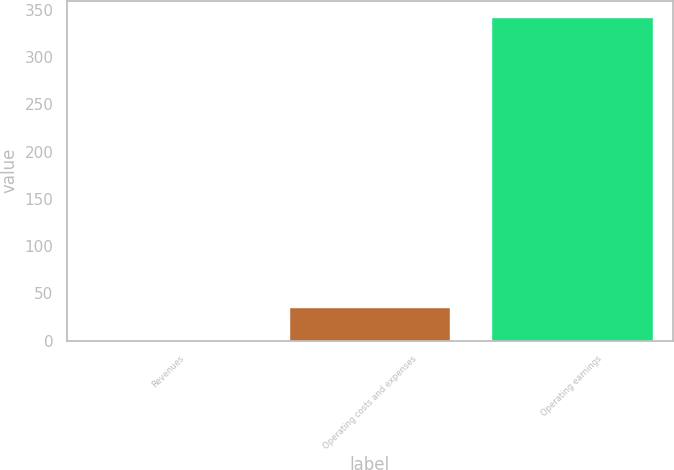Convert chart to OTSL. <chart><loc_0><loc_0><loc_500><loc_500><bar_chart><fcel>Revenues<fcel>Operating costs and expenses<fcel>Operating earnings<nl><fcel>0.9<fcel>35.05<fcel>342.4<nl></chart> 